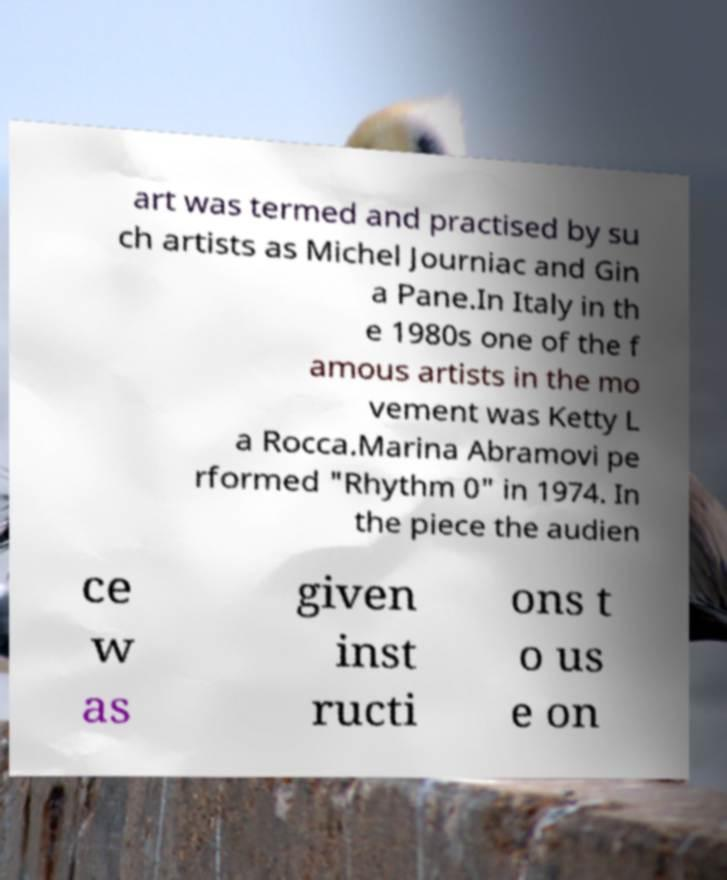Please identify and transcribe the text found in this image. art was termed and practised by su ch artists as Michel Journiac and Gin a Pane.In Italy in th e 1980s one of the f amous artists in the mo vement was Ketty L a Rocca.Marina Abramovi pe rformed "Rhythm 0" in 1974. In the piece the audien ce w as given inst ructi ons t o us e on 